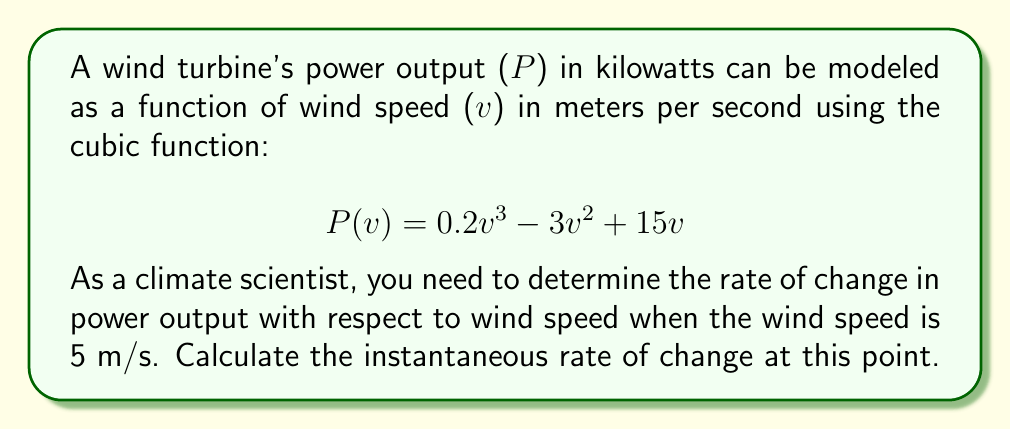Solve this math problem. To find the instantaneous rate of change in power output with respect to wind speed at 5 m/s, we need to calculate the derivative of the power function P(v) and evaluate it at v = 5.

1. First, let's find the derivative of P(v):
   $$ P(v) = 0.2v^3 - 3v^2 + 15v $$
   $$ P'(v) = 0.6v^2 - 6v + 15 $$

2. Now, we evaluate P'(v) at v = 5:
   $$ P'(5) = 0.6(5)^2 - 6(5) + 15 $$
   $$ = 0.6(25) - 30 + 15 $$
   $$ = 15 - 30 + 15 $$
   $$ = 0 $$

3. Interpret the result:
   The rate of change of power output with respect to wind speed at 5 m/s is 0 kW/(m/s). This means that at this specific wind speed, the power output is momentarily neither increasing nor decreasing as the wind speed changes.

4. Physical interpretation:
   This point (v = 5 m/s) represents a local maximum or minimum on the power curve. In the context of wind turbines, this could indicate a transition point in the turbine's performance characteristics.
Answer: The instantaneous rate of change in power output with respect to wind speed at 5 m/s is 0 kW/(m/s). 